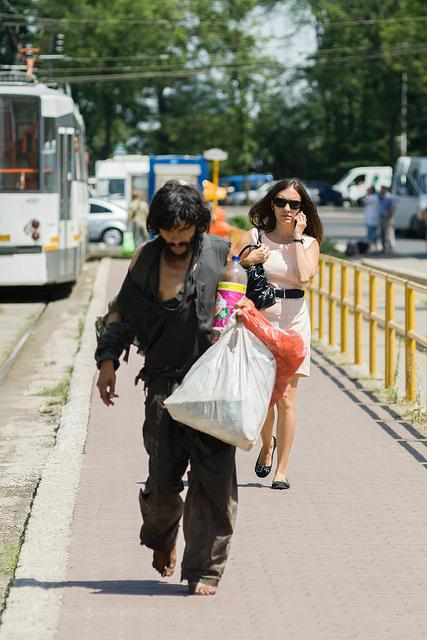What type of phone is the woman using? Please explain your reasoning. cellular. The woman is on the go.  the phone is mobile. 